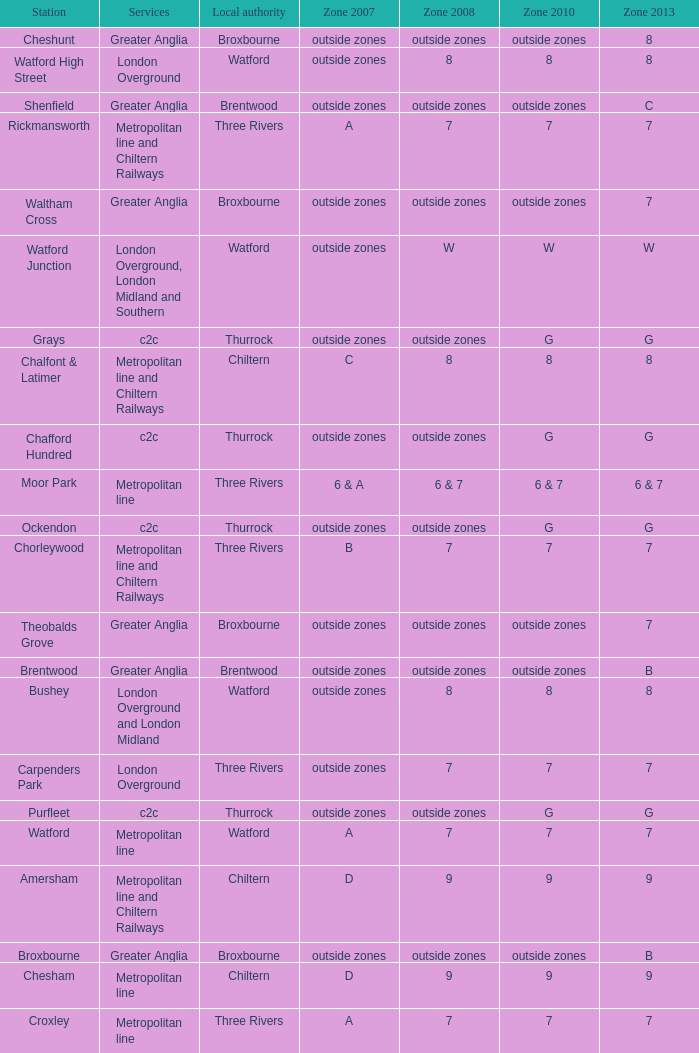Which Station has a Zone 2008 of 8, and a Zone 2007 of outside zones, and Services of london overground? Watford High Street. 